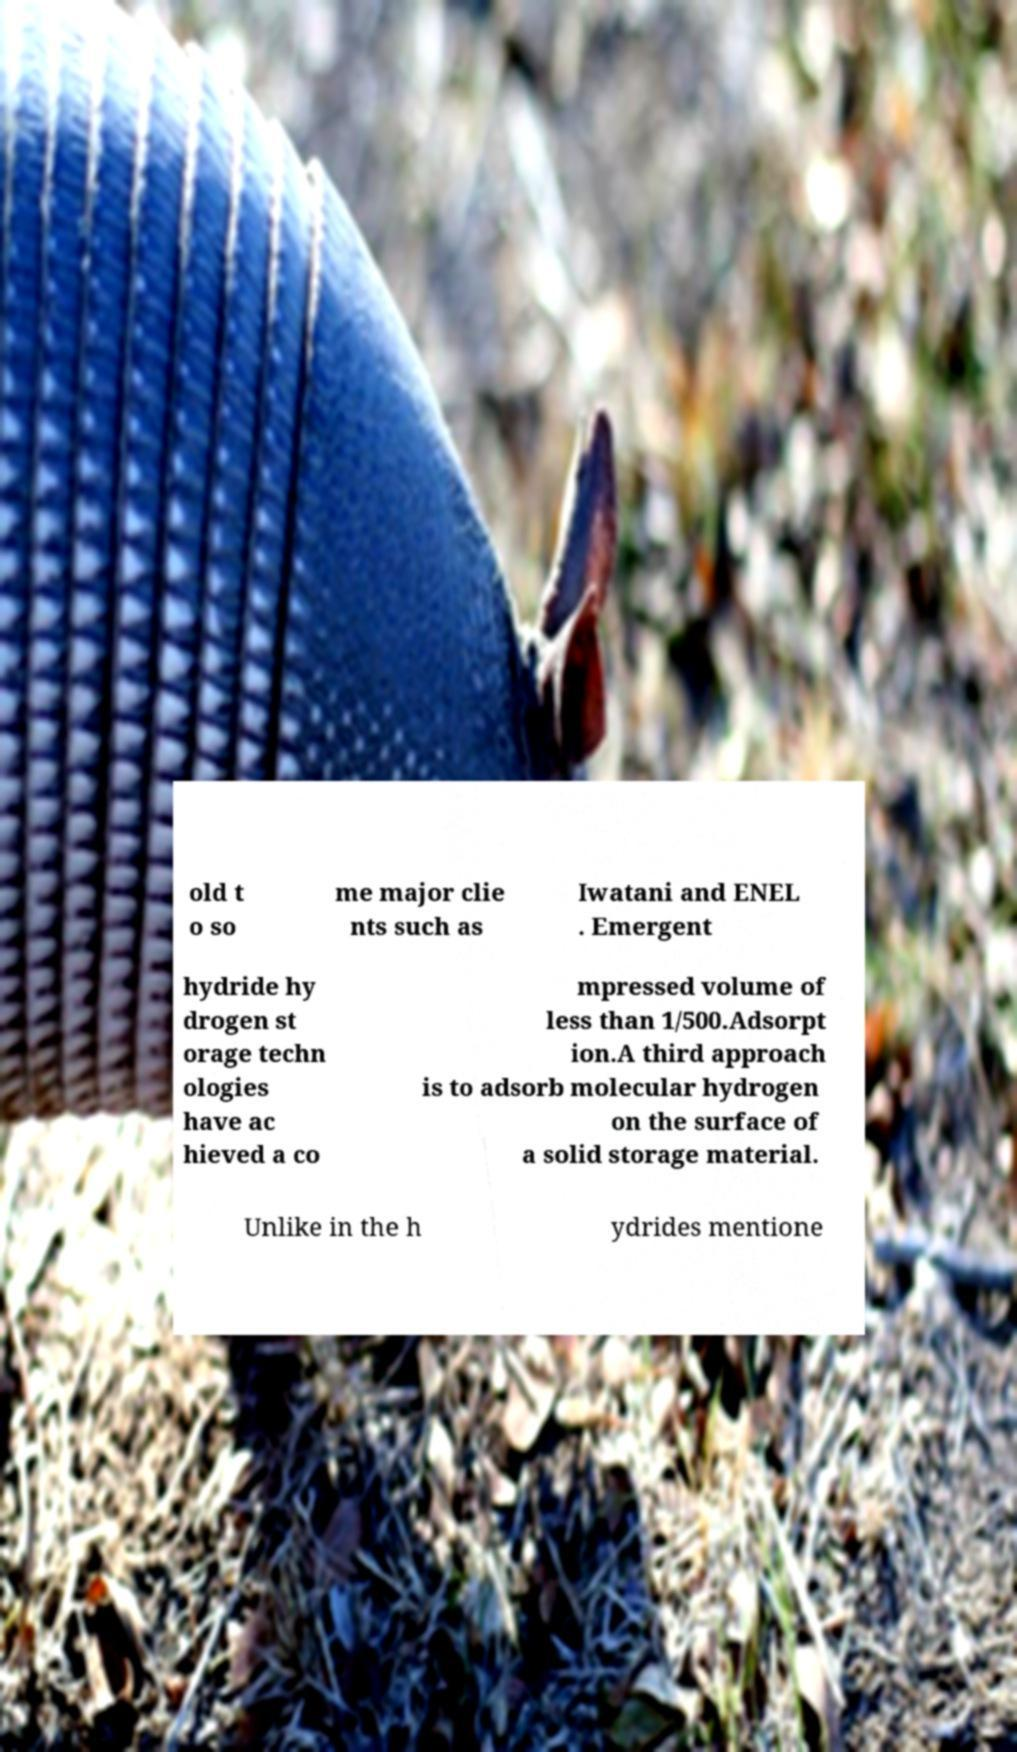What messages or text are displayed in this image? I need them in a readable, typed format. old t o so me major clie nts such as Iwatani and ENEL . Emergent hydride hy drogen st orage techn ologies have ac hieved a co mpressed volume of less than 1/500.Adsorpt ion.A third approach is to adsorb molecular hydrogen on the surface of a solid storage material. Unlike in the h ydrides mentione 